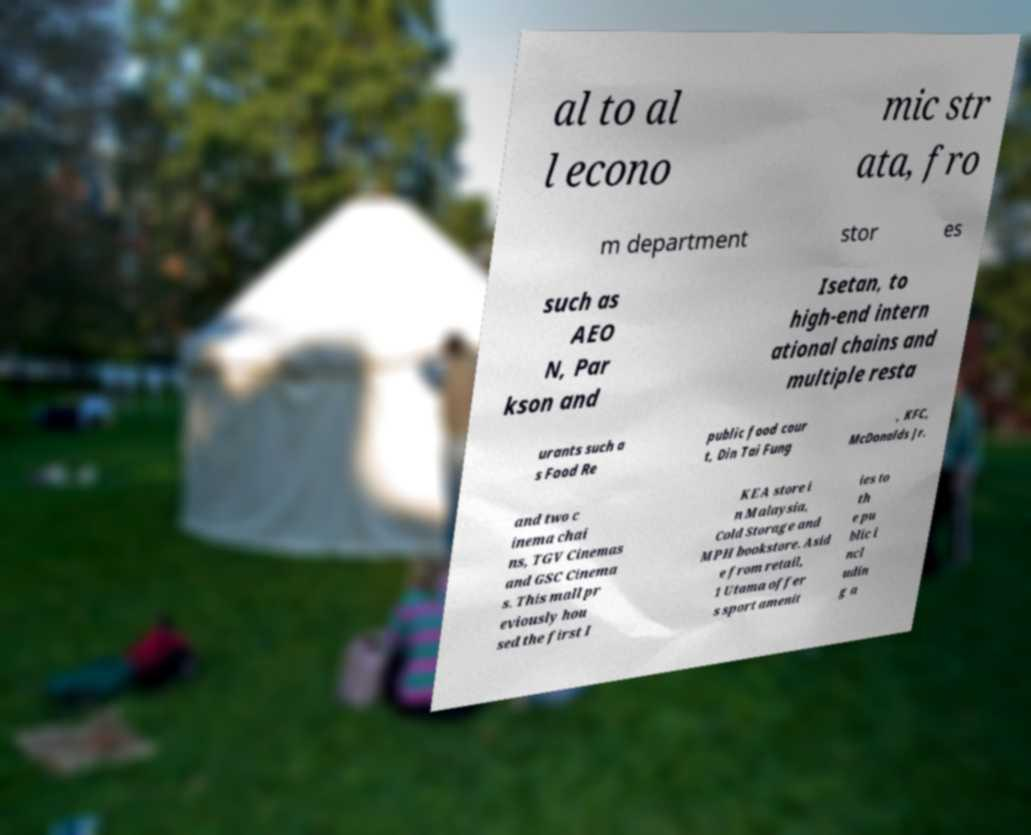I need the written content from this picture converted into text. Can you do that? al to al l econo mic str ata, fro m department stor es such as AEO N, Par kson and Isetan, to high-end intern ational chains and multiple resta urants such a s Food Re public food cour t, Din Tai Fung , KFC, McDonalds Jr. and two c inema chai ns, TGV Cinemas and GSC Cinema s. This mall pr eviously hou sed the first I KEA store i n Malaysia, Cold Storage and MPH bookstore. Asid e from retail, 1 Utama offer s sport amenit ies to th e pu blic i ncl udin g a 